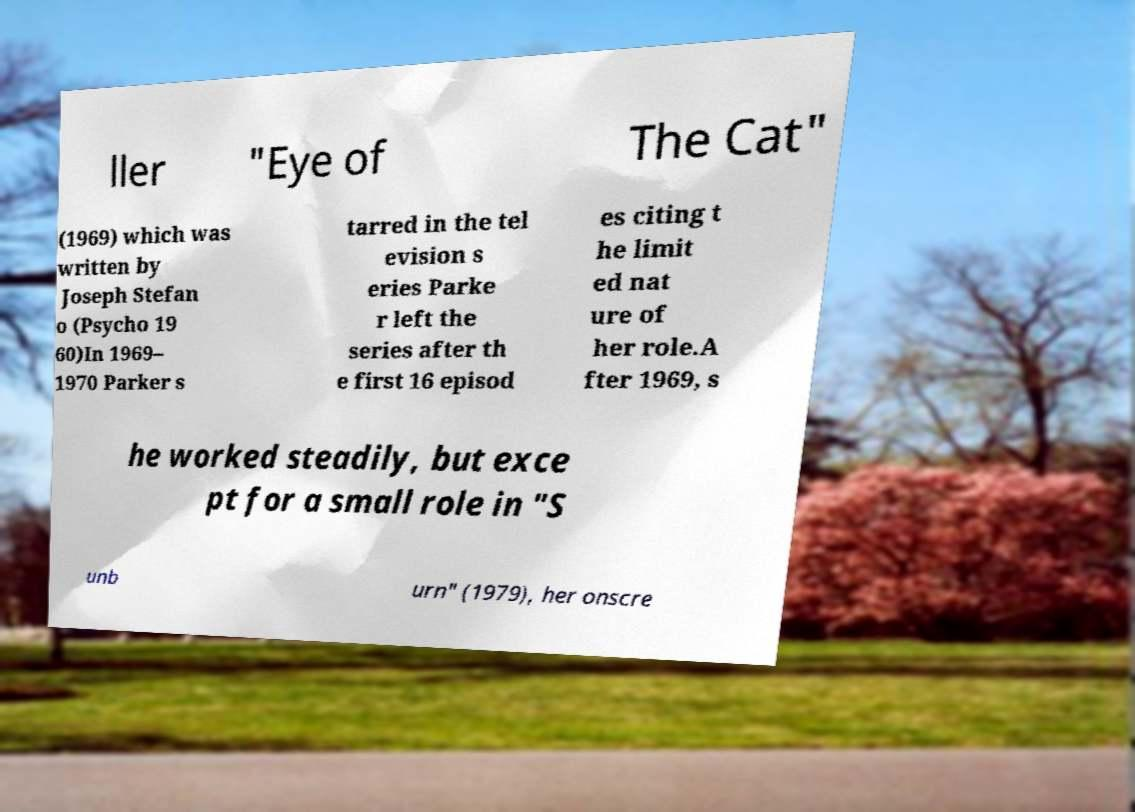Could you extract and type out the text from this image? ller "Eye of The Cat" (1969) which was written by Joseph Stefan o (Psycho 19 60)In 1969– 1970 Parker s tarred in the tel evision s eries Parke r left the series after th e first 16 episod es citing t he limit ed nat ure of her role.A fter 1969, s he worked steadily, but exce pt for a small role in "S unb urn" (1979), her onscre 